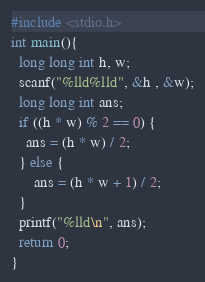Convert code to text. <code><loc_0><loc_0><loc_500><loc_500><_C_>#include <stdio.h>
int main(){
  long long int h, w;
  scanf("%lld%lld", &h , &w);
  long long int ans;
  if ((h * w) % 2 == 0) {
    ans = (h * w) / 2;
  } else {
      ans = (h * w + 1) / 2;
  }
  printf("%lld\n", ans);
  return 0;
}
</code> 